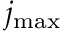Convert formula to latex. <formula><loc_0><loc_0><loc_500><loc_500>j _ { \max }</formula> 